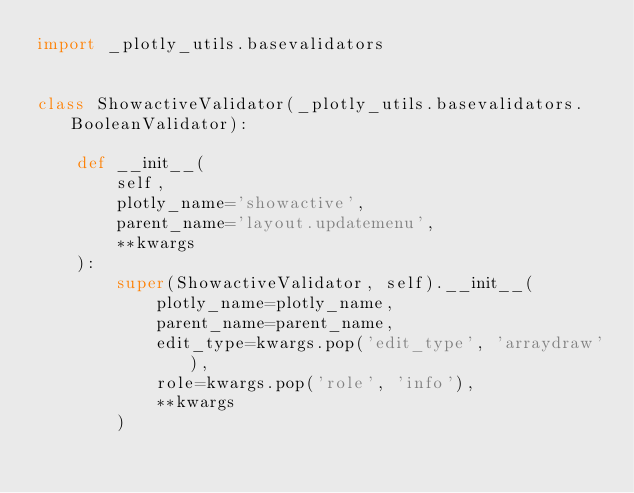Convert code to text. <code><loc_0><loc_0><loc_500><loc_500><_Python_>import _plotly_utils.basevalidators


class ShowactiveValidator(_plotly_utils.basevalidators.BooleanValidator):

    def __init__(
        self,
        plotly_name='showactive',
        parent_name='layout.updatemenu',
        **kwargs
    ):
        super(ShowactiveValidator, self).__init__(
            plotly_name=plotly_name,
            parent_name=parent_name,
            edit_type=kwargs.pop('edit_type', 'arraydraw'),
            role=kwargs.pop('role', 'info'),
            **kwargs
        )
</code> 